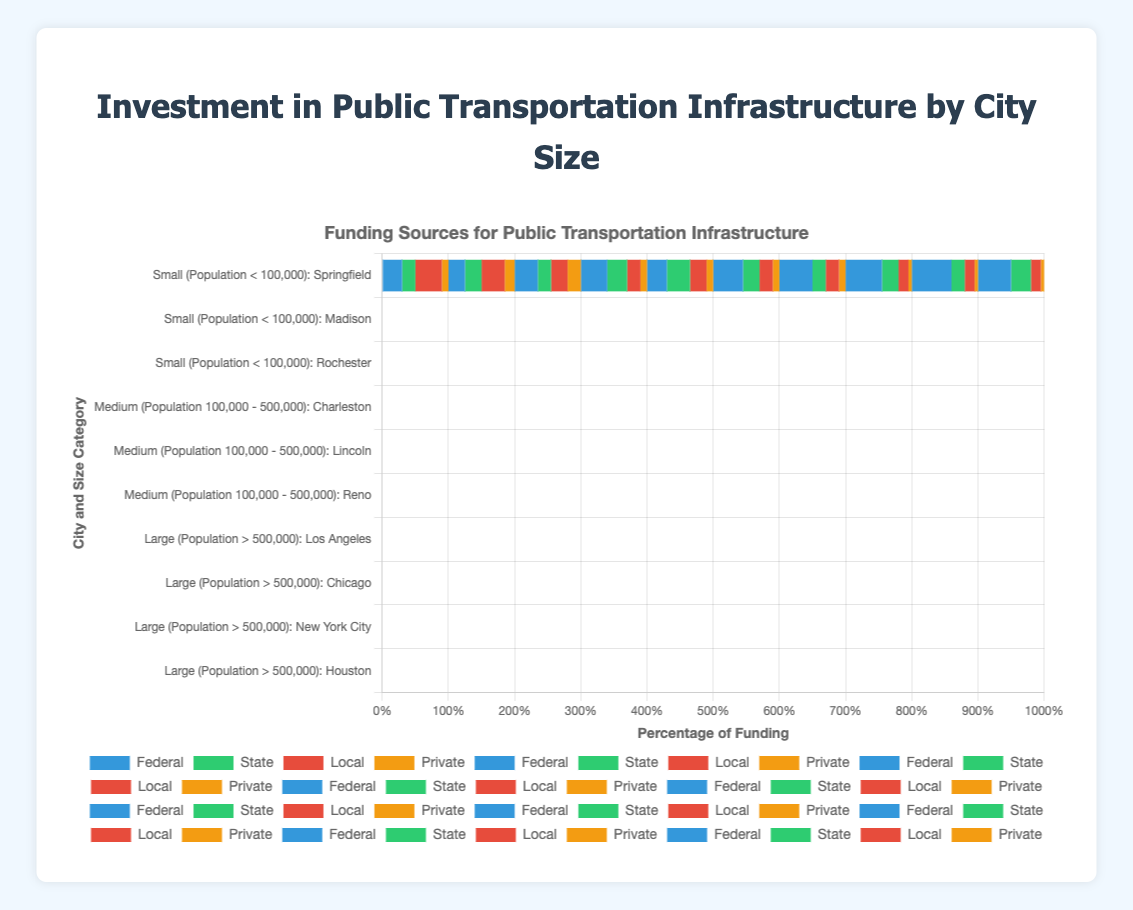What is the primary funding source for medium-sized cities like Charleston? Charleston has the highest proportion of Federal funding at 40% followed by State funding at 30%, making the Federal funding the primary source.
Answer: Federal Which city has the lowest proportion of State funding in large-sized cities? Among the large-sized cities (Los Angeles, Chicago, New York City, Houston), Chicago and New York City both have 20% State funding, which is the lowest proportion in this category.
Answer: Chicago and New York City How much greater is the Federal funding proportion for New York City compared to Lincoln? New York City has 60% Federal funding, and Lincoln has 30% Federal funding. The difference is 60% - 30% = 30%.
Answer: 30% What is the total percentage of Local funding in medium-sized cities? Adding the Local funding proportion for Charleston (20%), Lincoln (25%), and Reno (20%) gives 20% + 25% + 20% = 65%.
Answer: 65% Which city has the smallest percentage of Private funding among all the cities listed? The smallest percentage of Private funding in the chart is 5%, which belongs to Chicago and New York City among the large-sized cities.
Answer: Chicago and New York City Compare the proportions of Local funding between small-sized and large-sized cities. Which category has the higher average proportion of Local funding? For small-sized cities (Springfield: 40%, Madison: 35%, Rochester: 25%), the average is (40 + 35 + 25) / 3 = 33.33%. For large-sized cities (Los Angeles: 20%, Chicago: 15%, New York City: 15%, Houston: 15%), the average is (20 + 15 + 15 + 15) / 4 = 16.25%. Small-sized cities have a higher average proportion.
Answer: Small-sized cities What is the sum of State and Private funding proportions for Houston? Houston has 30% State funding and 5% Private funding. The total is 30% + 5% = 35%.
Answer: 35% Identify the city with the highest overall proportion of Federal funding and its value. New York City has the highest proportion of Federal funding at 60%.
Answer: New York City, 60% How does the sum of Local and Private funding percentages for Madison compare to those of Reno? Madison has Local (35%) + Private (15%) = 50%, and Reno has Local (20%) + Private (10%) = 30%. Madison's sum is 20% higher than Reno's.
Answer: Madison's sum is higher by 20% Which city relies most heavily on State funding and by what percentage? Lincoln relies most heavily on State funding with 35%.
Answer: Lincoln, 35% 